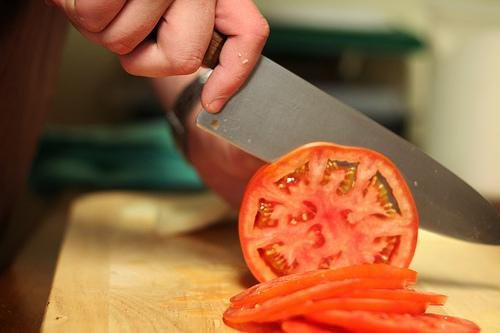Question: what kind of food is this?
Choices:
A. Tomato.
B. Apple.
C. Sweet pepper.
D. Radish.
Answer with the letter. Answer: A Question: what kind of knife is being used?
Choices:
A. Carving knife.
B. Paring knife.
C. Boning knife.
D. Chef's knife.
Answer with the letter. Answer: D 